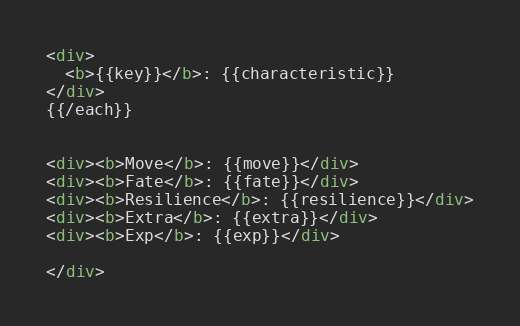Convert code to text. <code><loc_0><loc_0><loc_500><loc_500><_HTML_><div>
  <b>{{key}}</b>: {{characteristic}}
</div>
{{/each}}


<div><b>Move</b>: {{move}}</div>
<div><b>Fate</b>: {{fate}}</div>
<div><b>Resilience</b>: {{resilience}}</div>
<div><b>Extra</b>: {{extra}}</div>
<div><b>Exp</b>: {{exp}}</div>

</div>
</code> 